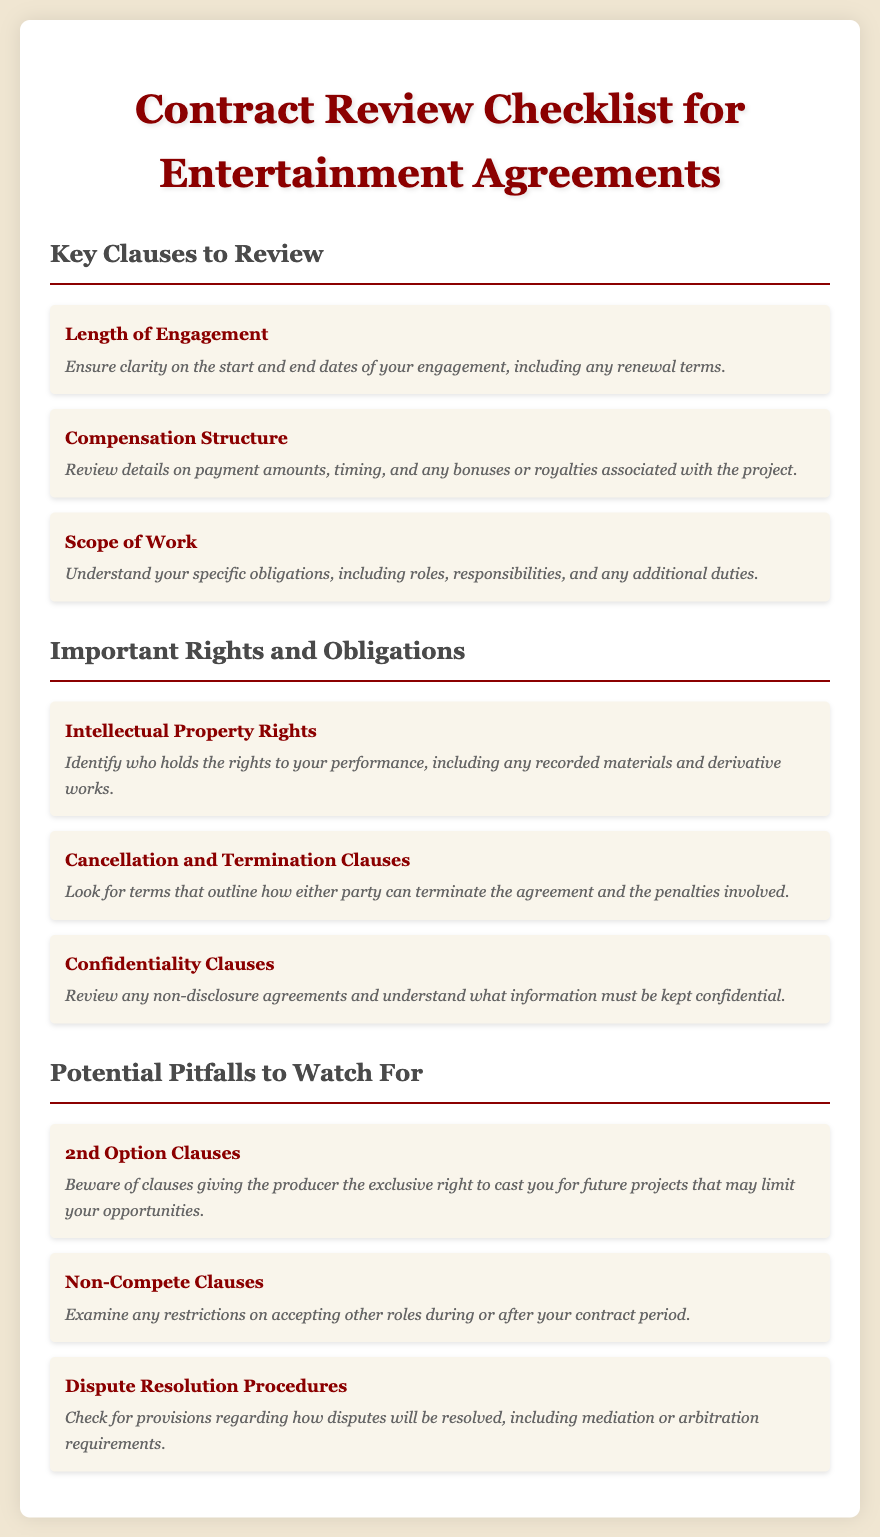What are the key clauses to review? The document lists key clauses such as Length of Engagement, Compensation Structure, and Scope of Work.
Answer: Length of Engagement, Compensation Structure, Scope of Work What does the Compensation Structure include? The Compensation Structure specifies details on payment amounts, timing, and any bonuses or royalties associated with the project.
Answer: Payment amounts, timing, bonuses, royalties What does the Intellectual Property Rights clause address? This clause identifies who holds the rights to your performance, including any recorded materials and derivative works.
Answer: Rights to performance, recorded materials, derivative works What is a potential pitfall mentioned in the document? The document lists several potential pitfalls, including 2nd Option Clauses, Non-Compete Clauses, and Dispute Resolution Procedures.
Answer: 2nd Option Clauses, Non-Compete Clauses, Dispute Resolution Procedures What should you verify regarding Cancellation and Termination Clauses? You should look for terms that outline how either party can terminate the agreement and the penalties involved.
Answer: Termination terms and penalties What obligations are addressed under Confidentiality Clauses? This clause requires you to review any non-disclosure agreements and understand what information must be kept confidential.
Answer: Non-disclosure agreements and confidential information What is meant by Non-Compete Clauses? These clauses examine any restrictions on accepting other roles during or after your contract period.
Answer: Restrictions on accepting other roles What does the document suggest regarding dispute resolution? The document indicates you should check for provisions regarding how disputes will be resolved, including mediation or arbitration requirements.
Answer: Mediation or arbitration requirements What specific aspect does the Length of Engagement clarify? It clarifies the start and end dates of your engagement, including any renewal terms.
Answer: Start and end dates, renewal terms 